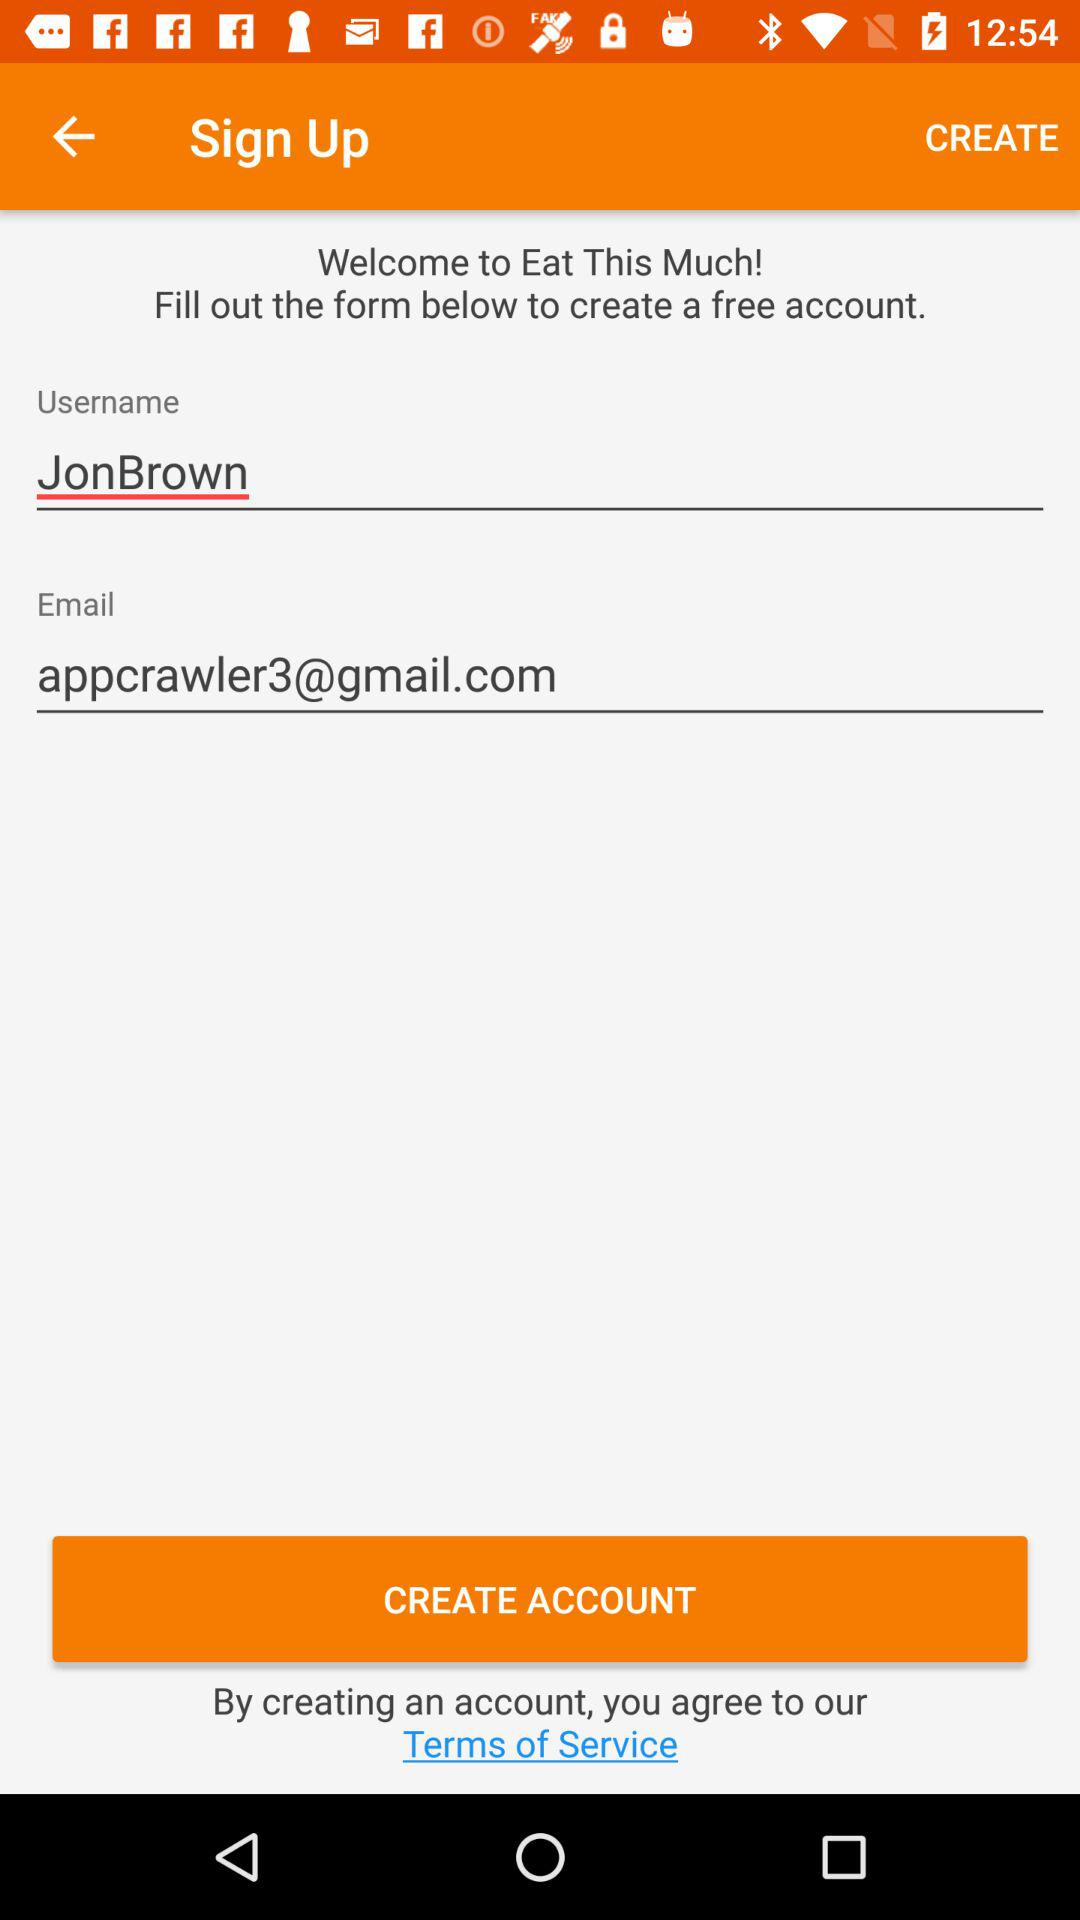What is the application name? The application name is "Eat This Much!". 